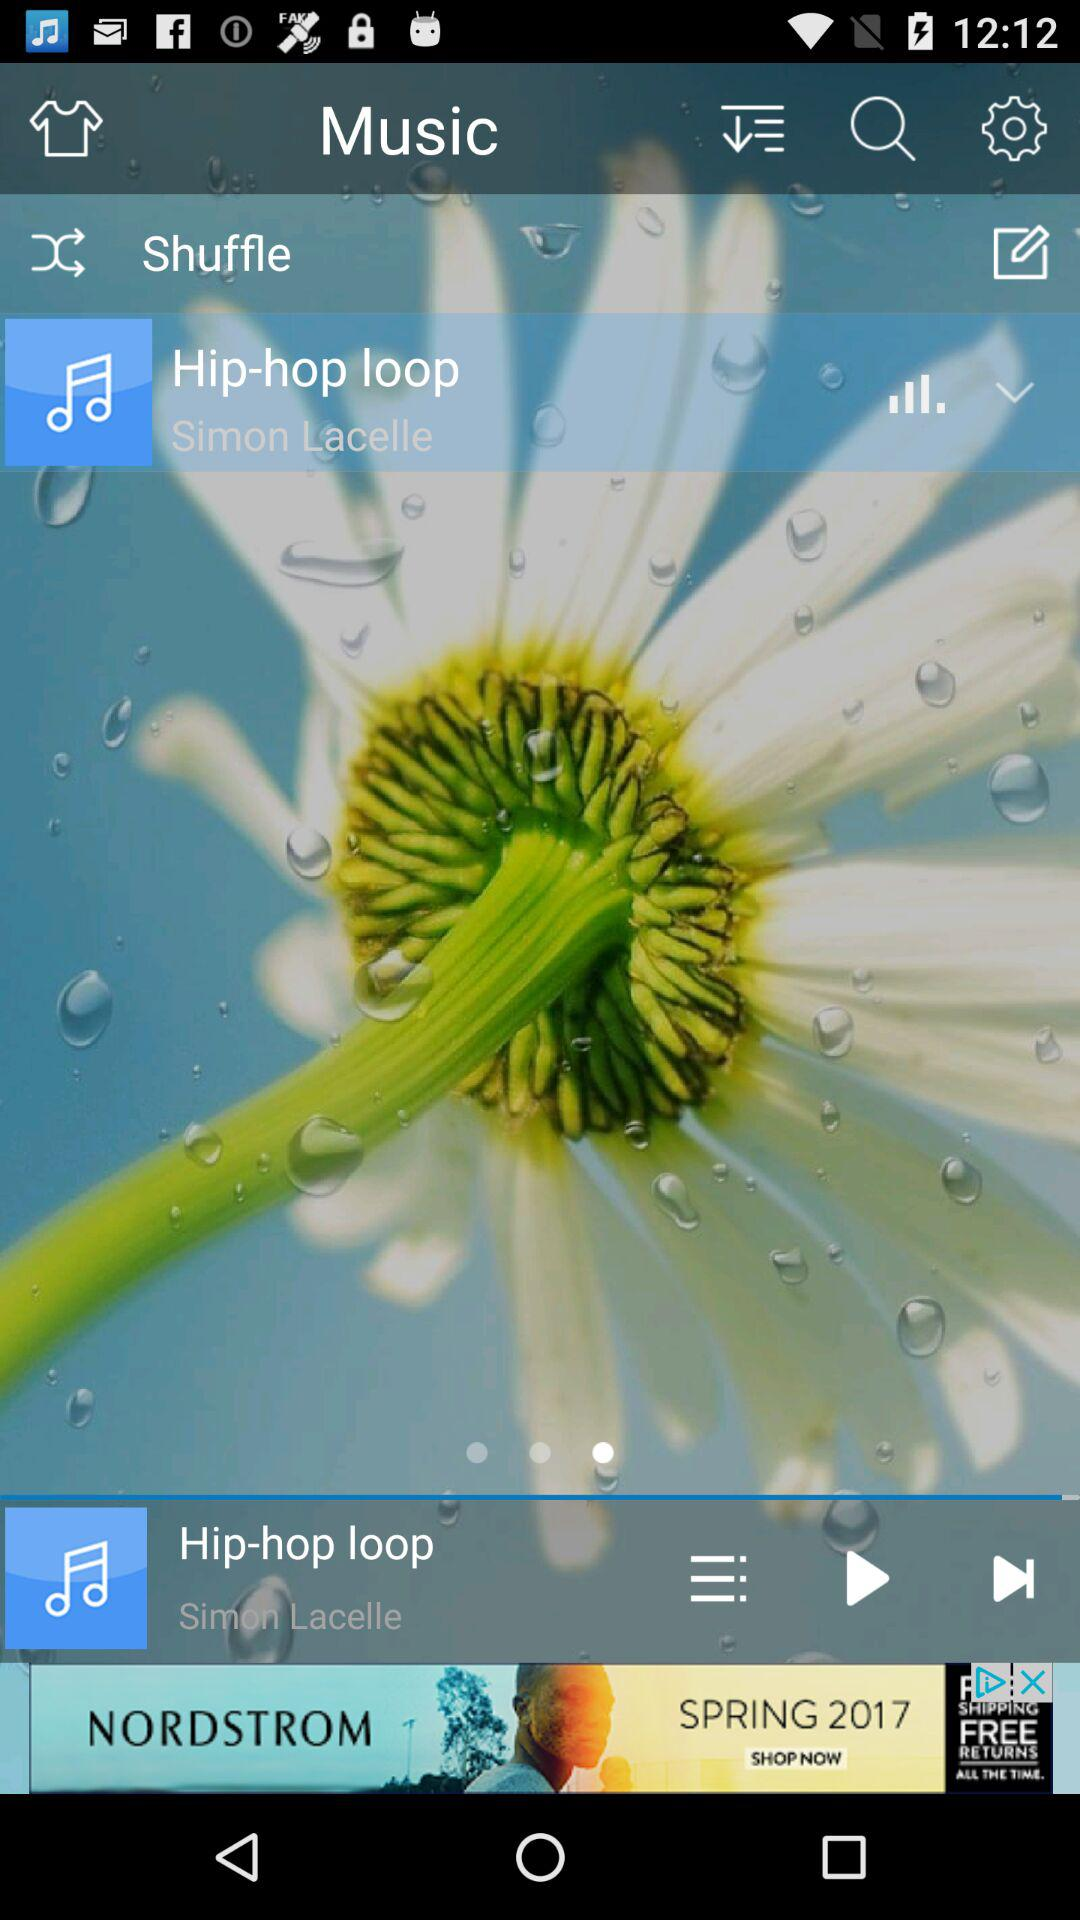Which song was last played? The last played song was "Hip-hop loop". 